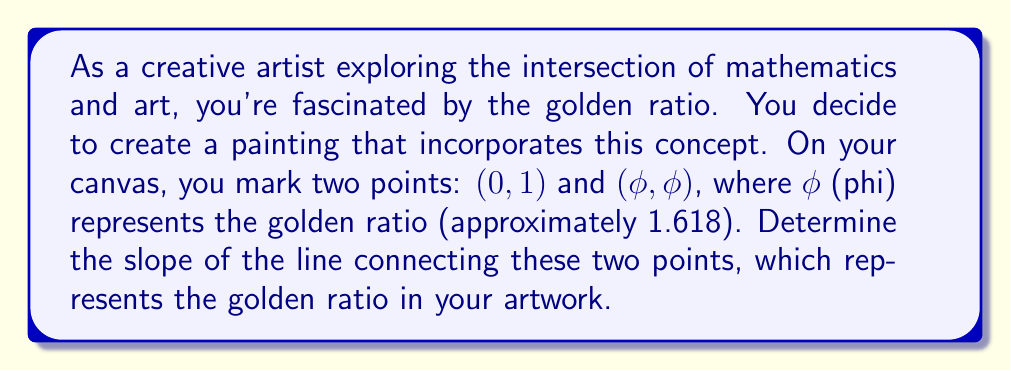Help me with this question. To solve this problem, we'll use the slope formula and the properties of the golden ratio. Let's break it down step-by-step:

1) The slope formula is:
   $$ m = \frac{y_2 - y_1}{x_2 - x_1} $$
   where $(x_1, y_1)$ and $(x_2, y_2)$ are two points on the line.

2) In this case, we have:
   $(x_1, y_1) = (0, 1)$ and $(x_2, y_2) = (\phi, \phi)$

3) Substituting these into the slope formula:
   $$ m = \frac{\phi - 1}{\phi - 0} = \frac{\phi - 1}{\phi} $$

4) Now, we can use a property of the golden ratio:
   $$ \phi^2 = \phi + 1 $$

5) Dividing both sides by φ:
   $$ \phi = 1 + \frac{1}{\phi} $$

6) Subtracting 1 from both sides:
   $$ \phi - 1 = \frac{1}{\phi} $$

7) Now, let's substitute this back into our slope equation:
   $$ m = \frac{\phi - 1}{\phi} = \frac{1/\phi}{\phi} = \frac{1}{\phi^2} $$

8) We know that $\phi^2 = \phi + 1$, so:
   $$ m = \frac{1}{\phi + 1} $$

9) The exact value of φ is $\frac{1 + \sqrt{5}}{2}$, so we could express the slope as:
   $$ m = \frac{1}{\frac{1 + \sqrt{5}}{2} + 1} = \frac{2}{3 + \sqrt{5}} $$

This slope represents the rate at which the golden ratio increases, capturing its essence in a linear form on your canvas.
Answer: $m = \frac{1}{\phi + 1} = \frac{2}{3 + \sqrt{5}} \approx 0.381966$ 